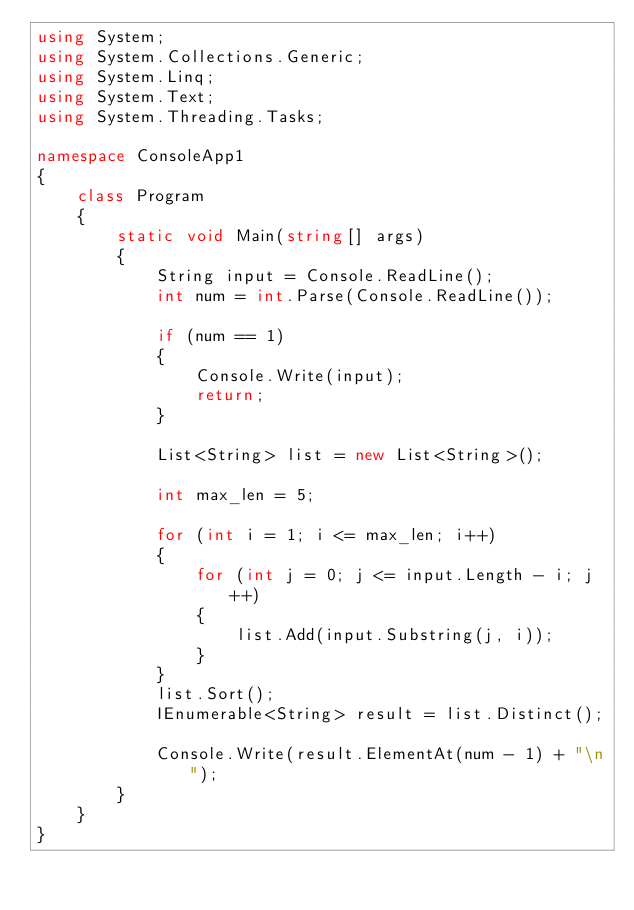<code> <loc_0><loc_0><loc_500><loc_500><_C#_>using System;
using System.Collections.Generic;
using System.Linq;
using System.Text;
using System.Threading.Tasks;

namespace ConsoleApp1
{
    class Program
    {
        static void Main(string[] args)
        {
            String input = Console.ReadLine();
            int num = int.Parse(Console.ReadLine());

            if (num == 1)
            {
                Console.Write(input);
                return;
            }

            List<String> list = new List<String>();

            int max_len = 5;

            for (int i = 1; i <= max_len; i++)
            {
                for (int j = 0; j <= input.Length - i; j++)
                {
                    list.Add(input.Substring(j, i));
                }
            }
            list.Sort();
            IEnumerable<String> result = list.Distinct();

            Console.Write(result.ElementAt(num - 1) + "\n");
        }
    }
}</code> 